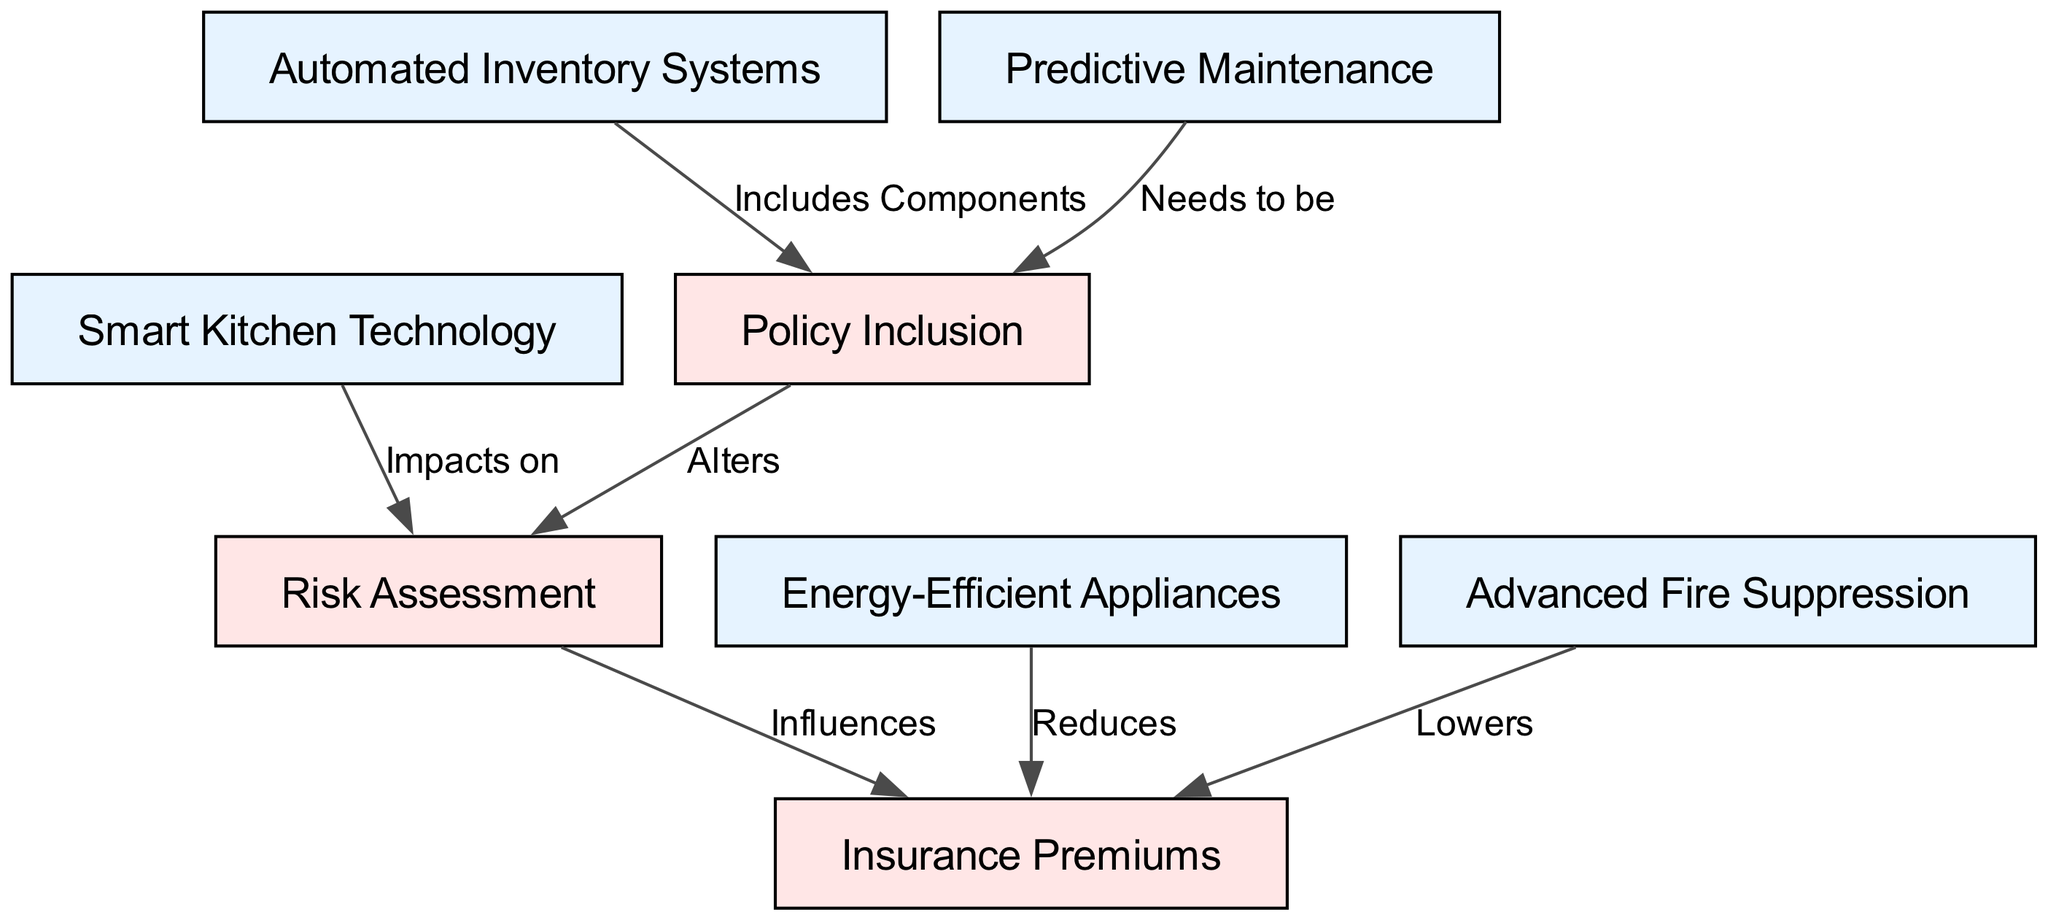What is the total number of nodes in the diagram? The diagram has 8 nodes: Smart Kitchen Technology, Energy-Efficient Appliances, Automated Inventory Systems, Advanced Fire Suppression, Predictive Maintenance, Insurance Premiums, Risk Assessment, and Policy Inclusion.
Answer: 8 What is the relationship between Smart Kitchen Technology and Risk Assessment? The edge from Smart Kitchen Technology to Risk Assessment is labeled "Impacts on," indicating that Smart Kitchen Technology influences how risk is assessed.
Answer: Impacts on Which node includes components of Automated Inventory Systems? The edge from Automated Inventory Systems to Policy Inclusion indicates that it includes components in the insurance policy coverage.
Answer: Policy Inclusion How do Energy-Efficient Appliances affect Insurance Premiums? The edge between Energy-Efficient Appliances and Insurance Premiums is labeled "Reduces," showing that they lower the insurance costs for restaurants using such appliances.
Answer: Reduces What influences the Insurance Premiums? The diagram shows that both Risk Assessment and Advanced Fire Suppression contribute to determining the Insurance Premiums, as they both have edges directed towards this node.
Answer: Risk Assessment, Advanced Fire Suppression How does Policy Inclusion alter Risk Assessment? The edge from Policy Inclusion to Risk Assessment is labeled "Alters," suggesting that the inclusion of certain terms in insurance policies can change how risk is evaluated in the context of restaurant equipment.
Answer: Alters Which nodes are connected to Insurance Premiums? The Insurance Premiums node has edges coming from Energy-Efficient Appliances and Advanced Fire Suppression, and from Risk Assessment, making these three nodes connected to it and impacting the insurance cost.
Answer: Energy-Efficient Appliances, Advanced Fire Suppression, Risk Assessment What is a result of Predictive Maintenance in the context of insurance? Predictive Maintenance leads to adjustments within the Policy Inclusion, meaning that having such systems in place changes what is included in the insurance policy for coverage.
Answer: Needs to be Which technology impacts Risk Assessment in the diagram? The only node that has a direct impact on Risk Assessment according to the diagram is Smart Kitchen Technology, as shown by the edge labeled "Impacts on."
Answer: Smart Kitchen Technology 